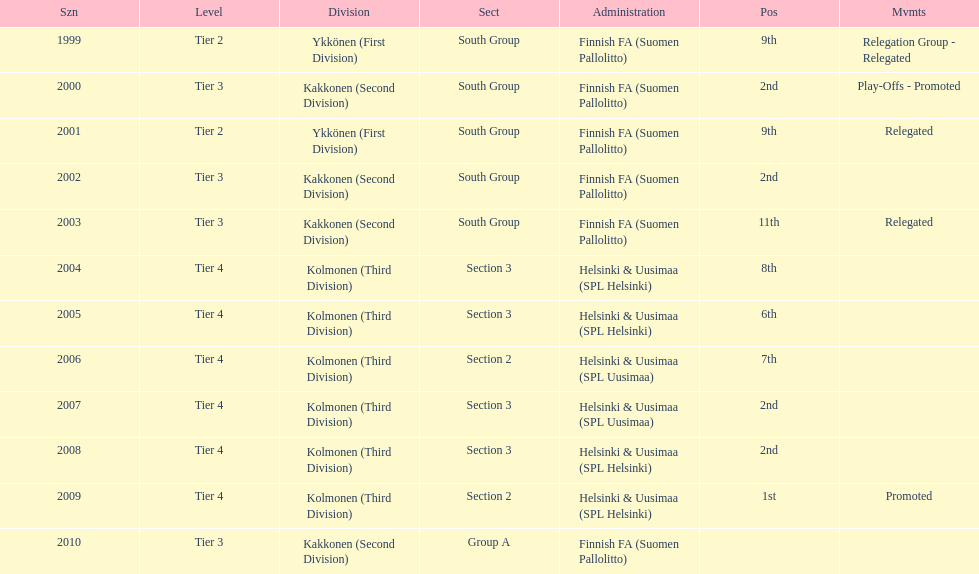Can you give me this table as a dict? {'header': ['Szn', 'Level', 'Division', 'Sect', 'Administration', 'Pos', 'Mvmts'], 'rows': [['1999', 'Tier 2', 'Ykkönen (First Division)', 'South Group', 'Finnish FA (Suomen Pallolitto)', '9th', 'Relegation Group - Relegated'], ['2000', 'Tier 3', 'Kakkonen (Second Division)', 'South Group', 'Finnish FA (Suomen Pallolitto)', '2nd', 'Play-Offs - Promoted'], ['2001', 'Tier 2', 'Ykkönen (First Division)', 'South Group', 'Finnish FA (Suomen Pallolitto)', '9th', 'Relegated'], ['2002', 'Tier 3', 'Kakkonen (Second Division)', 'South Group', 'Finnish FA (Suomen Pallolitto)', '2nd', ''], ['2003', 'Tier 3', 'Kakkonen (Second Division)', 'South Group', 'Finnish FA (Suomen Pallolitto)', '11th', 'Relegated'], ['2004', 'Tier 4', 'Kolmonen (Third Division)', 'Section 3', 'Helsinki & Uusimaa (SPL Helsinki)', '8th', ''], ['2005', 'Tier 4', 'Kolmonen (Third Division)', 'Section 3', 'Helsinki & Uusimaa (SPL Helsinki)', '6th', ''], ['2006', 'Tier 4', 'Kolmonen (Third Division)', 'Section 2', 'Helsinki & Uusimaa (SPL Uusimaa)', '7th', ''], ['2007', 'Tier 4', 'Kolmonen (Third Division)', 'Section 3', 'Helsinki & Uusimaa (SPL Uusimaa)', '2nd', ''], ['2008', 'Tier 4', 'Kolmonen (Third Division)', 'Section 3', 'Helsinki & Uusimaa (SPL Helsinki)', '2nd', ''], ['2009', 'Tier 4', 'Kolmonen (Third Division)', 'Section 2', 'Helsinki & Uusimaa (SPL Helsinki)', '1st', 'Promoted'], ['2010', 'Tier 3', 'Kakkonen (Second Division)', 'Group A', 'Finnish FA (Suomen Pallolitto)', '', '']]} In how many continuous occurrences did they play in tier 4? 6. 